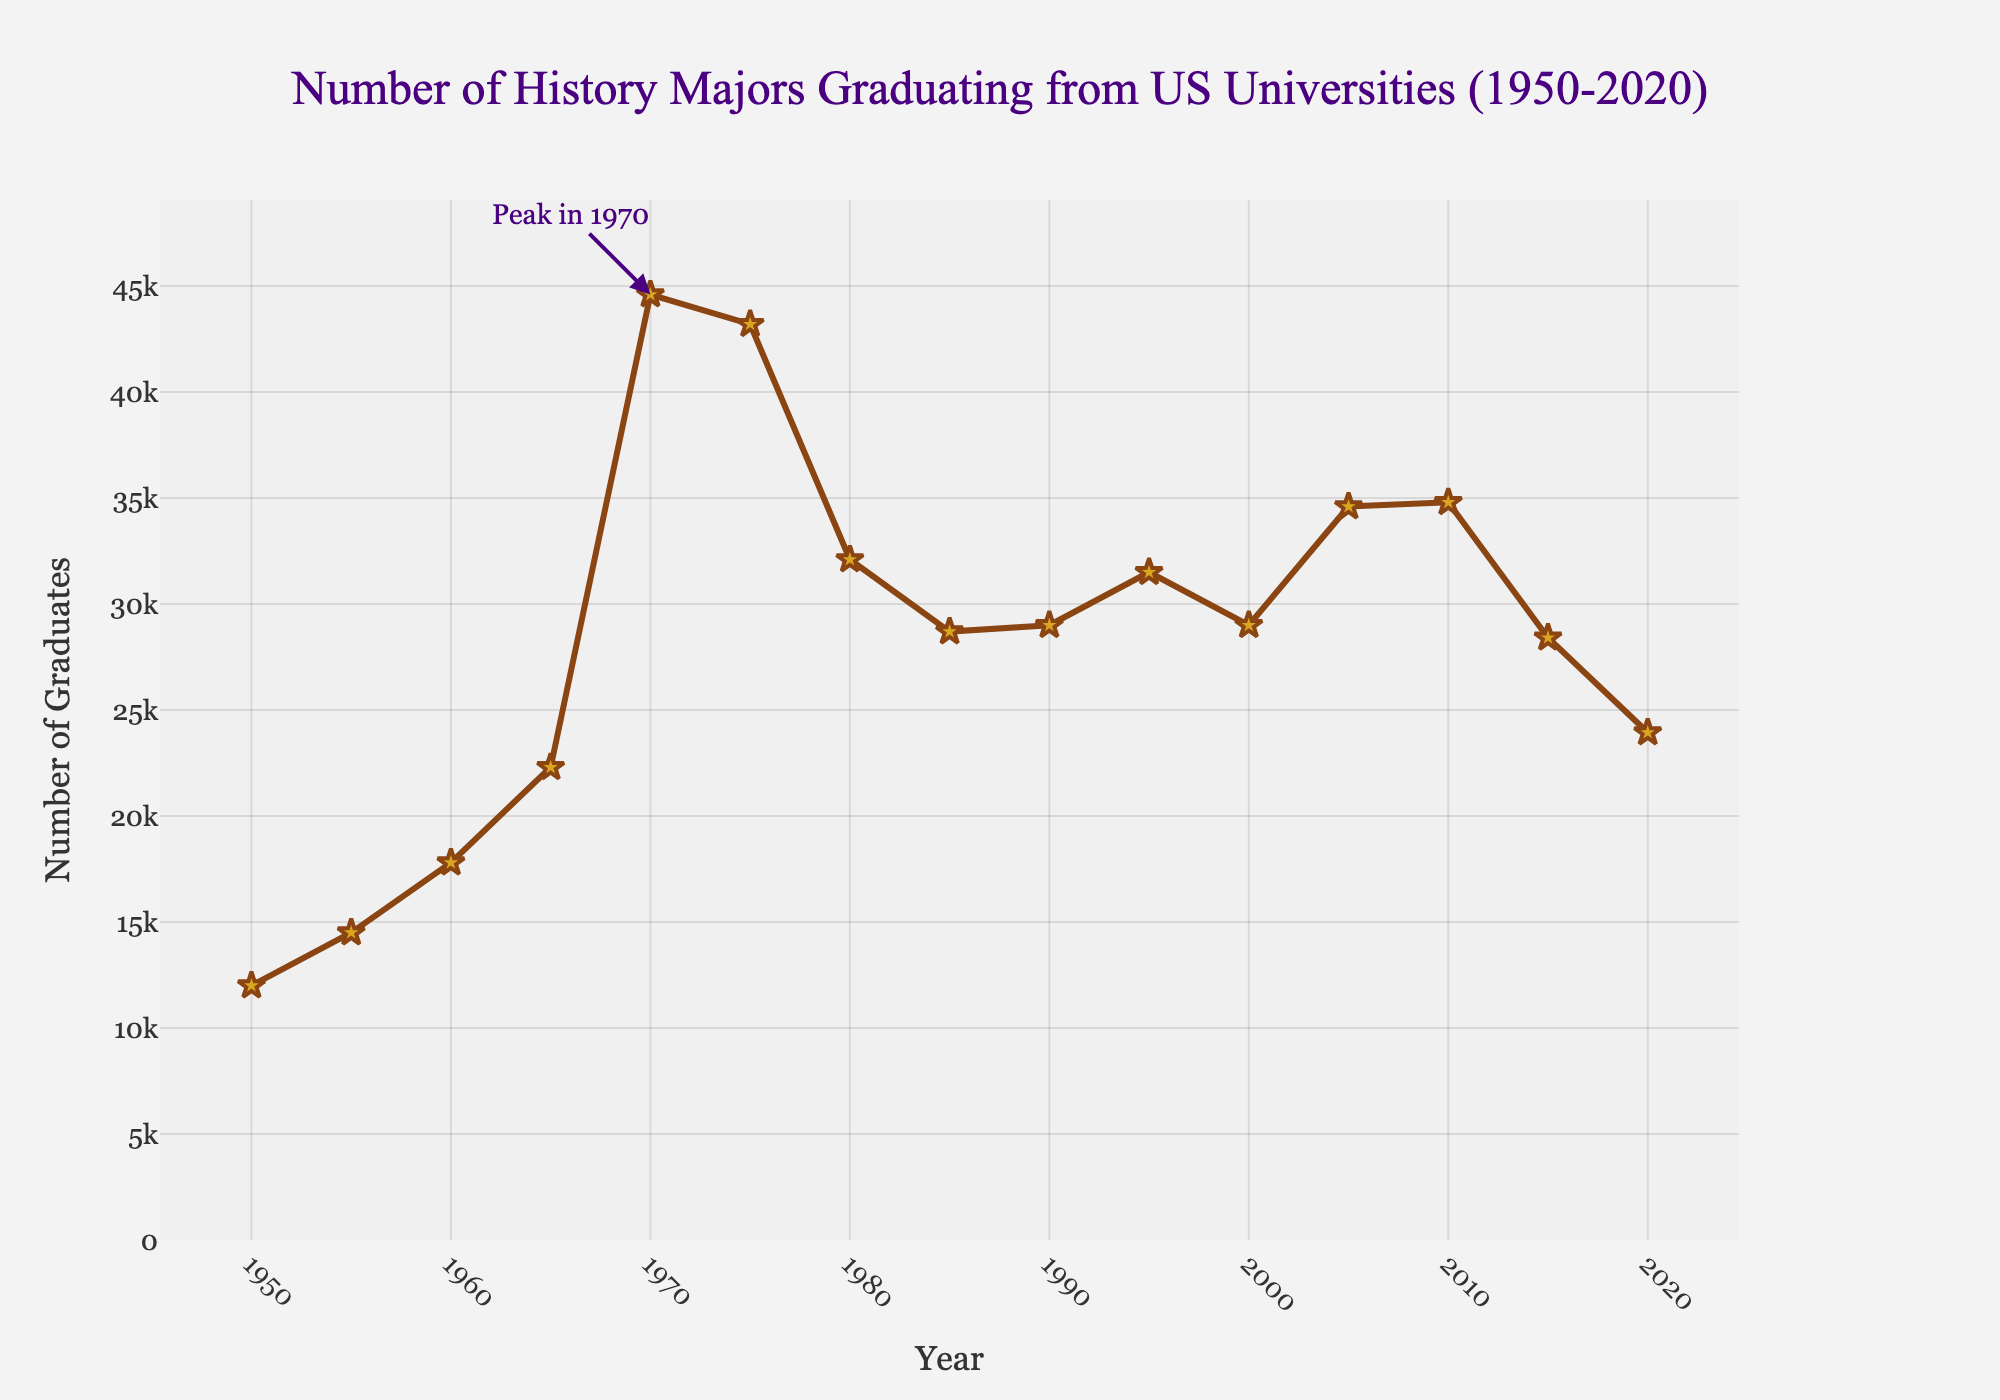what is the highest number of history majors graduating in a single year? The highest number is indicated by the peak value on the chart. This peak is annotated with "Peak in 1970" at 44600 graduates.
Answer: 44600 what is the difference in the number of history majors graduating between 1970 and 2020? Subtract the number of graduates in 2020 from the number of graduates in 1970. 44600 (1970) - 23940 (2020) = 20660.
Answer: 20660 how many years had fewer than 20000 history majors graduating? Count the number of years where the graph line is below the 20000 mark. No years in the dataset have fewer than 20000 graduates.
Answer: 0 which year saw a greater number of history majors graduating, 1980 or 2000? Compare the data points for 1980 (32100) and 2000 (29000). 32100 is greater than 29000.
Answer: 1980 in which year did the number of history majors graduating first exceed 30000? Find the first year in the dataset where the number of graduates is above 30000. This occurs first in 1970 with 44600 graduates.
Answer: 1970 what was the average number of history majors graduating per year during 1950s (1950-1959)? Calculate the sum of graduates during the years 1950, 1955, and average them. (12000 + 14500) / 2 = 26500 / 2 = 13250.
Answer: 13250 what is the trend in the number of history majors graduating from 1960 to 2015? Observe the graph from 1960 (17800) to 2015 (28410). There is an overall increase until 1970, a decline by 1980, slight fluctuation, and another decrease after 2010.
Answer: fluctuating decline did the number of history majors graduating increase or decrease between 1975 and 1980? Compare the numbers in 1975 (43200) and 1980 (32100). The number decreased from 43200 to 32100.
Answer: decrease which decade saw the most significant reduction in the number of history majors graduating? Compare the reductions across decades. The most significant drop is between 1970 (44600) and 1980 (32100) in the 1970s.
Answer: 1970s what visual feature marks the year with the peak number of graduates? The peak year 1970 is marked with an annotation "Peak in 1970".
Answer: annotation 